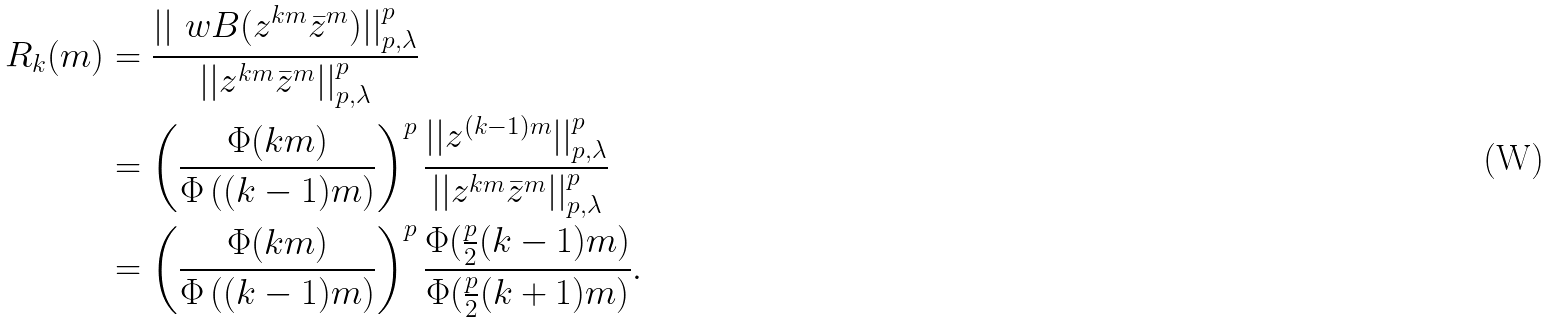Convert formula to latex. <formula><loc_0><loc_0><loc_500><loc_500>R _ { k } ( m ) & = \frac { | | \ w B ( z ^ { k m } \bar { z } ^ { m } ) | | _ { p , \lambda } ^ { p } } { | | z ^ { k m } \bar { z } ^ { m } | | _ { p , \lambda } ^ { p } } \\ & = \left ( \frac { \Phi ( k m ) } { \Phi \left ( ( k - 1 ) m \right ) } \right ) ^ { p } \frac { | | z ^ { ( k - 1 ) m } | | _ { p , \lambda } ^ { p } } { | | z ^ { k m } \bar { z } ^ { m } | | _ { p , \lambda } ^ { p } } \\ & = \left ( \frac { \Phi ( k m ) } { \Phi \left ( ( k - 1 ) m \right ) } \right ) ^ { p } \frac { \Phi ( \frac { p } { 2 } ( k - 1 ) m ) } { \Phi ( \frac { p } { 2 } ( k + 1 ) m ) } .</formula> 